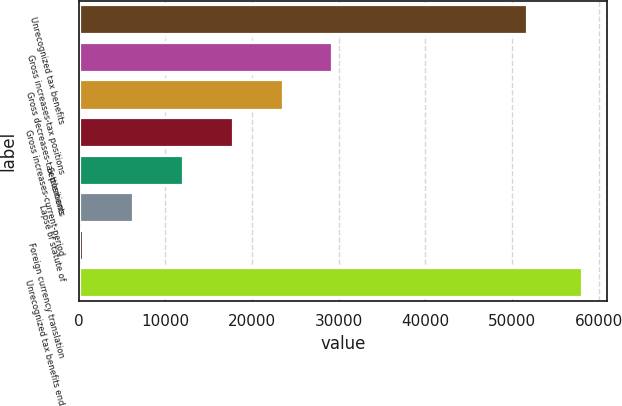Convert chart to OTSL. <chart><loc_0><loc_0><loc_500><loc_500><bar_chart><fcel>Unrecognized tax benefits<fcel>Gross increases-tax positions<fcel>Gross decreases-tax positions<fcel>Gross increases-current-period<fcel>Settlements<fcel>Lapse of statute of<fcel>Foreign currency translation<fcel>Unrecognized tax benefits end<nl><fcel>51740<fcel>29283<fcel>23517.6<fcel>17752.2<fcel>11986.8<fcel>6221.4<fcel>456<fcel>58110<nl></chart> 